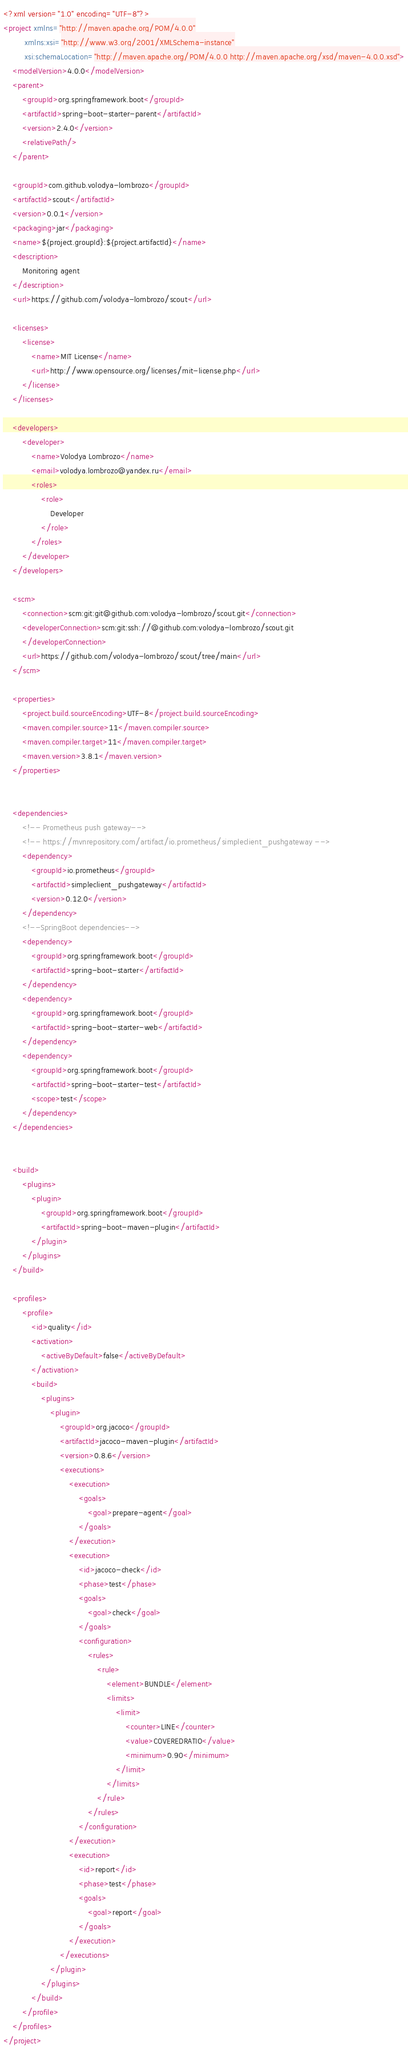Convert code to text. <code><loc_0><loc_0><loc_500><loc_500><_XML_><?xml version="1.0" encoding="UTF-8"?>
<project xmlns="http://maven.apache.org/POM/4.0.0"
         xmlns:xsi="http://www.w3.org/2001/XMLSchema-instance"
         xsi:schemaLocation="http://maven.apache.org/POM/4.0.0 http://maven.apache.org/xsd/maven-4.0.0.xsd">
    <modelVersion>4.0.0</modelVersion>
    <parent>
        <groupId>org.springframework.boot</groupId>
        <artifactId>spring-boot-starter-parent</artifactId>
        <version>2.4.0</version>
        <relativePath/>
    </parent>

    <groupId>com.github.volodya-lombrozo</groupId>
    <artifactId>scout</artifactId>
    <version>0.0.1</version>
    <packaging>jar</packaging>
    <name>${project.groupId}:${project.artifactId}</name>
    <description>
        Monitoring agent
    </description>
    <url>https://github.com/volodya-lombrozo/scout</url>

    <licenses>
        <license>
            <name>MIT License</name>
            <url>http://www.opensource.org/licenses/mit-license.php</url>
        </license>
    </licenses>

    <developers>
        <developer>
            <name>Volodya Lombrozo</name>
            <email>volodya.lombrozo@yandex.ru</email>
            <roles>
                <role>
                    Developer
                </role>
            </roles>
        </developer>
    </developers>

    <scm>
        <connection>scm:git:git@github.com:volodya-lombrozo/scout.git</connection>
        <developerConnection>scm:git:ssh://@github.com:volodya-lombrozo/scout.git
        </developerConnection>
        <url>https://github.com/volodya-lombrozo/scout/tree/main</url>
    </scm>

    <properties>
        <project.build.sourceEncoding>UTF-8</project.build.sourceEncoding>
        <maven.compiler.source>11</maven.compiler.source>
        <maven.compiler.target>11</maven.compiler.target>
        <maven.version>3.8.1</maven.version>
    </properties>


    <dependencies>
        <!-- Prometheus push gateway-->
        <!-- https://mvnrepository.com/artifact/io.prometheus/simpleclient_pushgateway -->
        <dependency>
            <groupId>io.prometheus</groupId>
            <artifactId>simpleclient_pushgateway</artifactId>
            <version>0.12.0</version>
        </dependency>
        <!--SpringBoot dependencies-->
        <dependency>
            <groupId>org.springframework.boot</groupId>
            <artifactId>spring-boot-starter</artifactId>
        </dependency>
        <dependency>
            <groupId>org.springframework.boot</groupId>
            <artifactId>spring-boot-starter-web</artifactId>
        </dependency>
        <dependency>
            <groupId>org.springframework.boot</groupId>
            <artifactId>spring-boot-starter-test</artifactId>
            <scope>test</scope>
        </dependency>
    </dependencies>


    <build>
        <plugins>
            <plugin>
                <groupId>org.springframework.boot</groupId>
                <artifactId>spring-boot-maven-plugin</artifactId>
            </plugin>
        </plugins>
    </build>

    <profiles>
        <profile>
            <id>quality</id>
            <activation>
                <activeByDefault>false</activeByDefault>
            </activation>
            <build>
                <plugins>
                    <plugin>
                        <groupId>org.jacoco</groupId>
                        <artifactId>jacoco-maven-plugin</artifactId>
                        <version>0.8.6</version>
                        <executions>
                            <execution>
                                <goals>
                                    <goal>prepare-agent</goal>
                                </goals>
                            </execution>
                            <execution>
                                <id>jacoco-check</id>
                                <phase>test</phase>
                                <goals>
                                    <goal>check</goal>
                                </goals>
                                <configuration>
                                    <rules>
                                        <rule>
                                            <element>BUNDLE</element>
                                            <limits>
                                                <limit>
                                                    <counter>LINE</counter>
                                                    <value>COVEREDRATIO</value>
                                                    <minimum>0.90</minimum>
                                                </limit>
                                            </limits>
                                        </rule>
                                    </rules>
                                </configuration>
                            </execution>
                            <execution>
                                <id>report</id>
                                <phase>test</phase>
                                <goals>
                                    <goal>report</goal>
                                </goals>
                            </execution>
                        </executions>
                    </plugin>
                </plugins>
            </build>
        </profile>
    </profiles>
</project></code> 